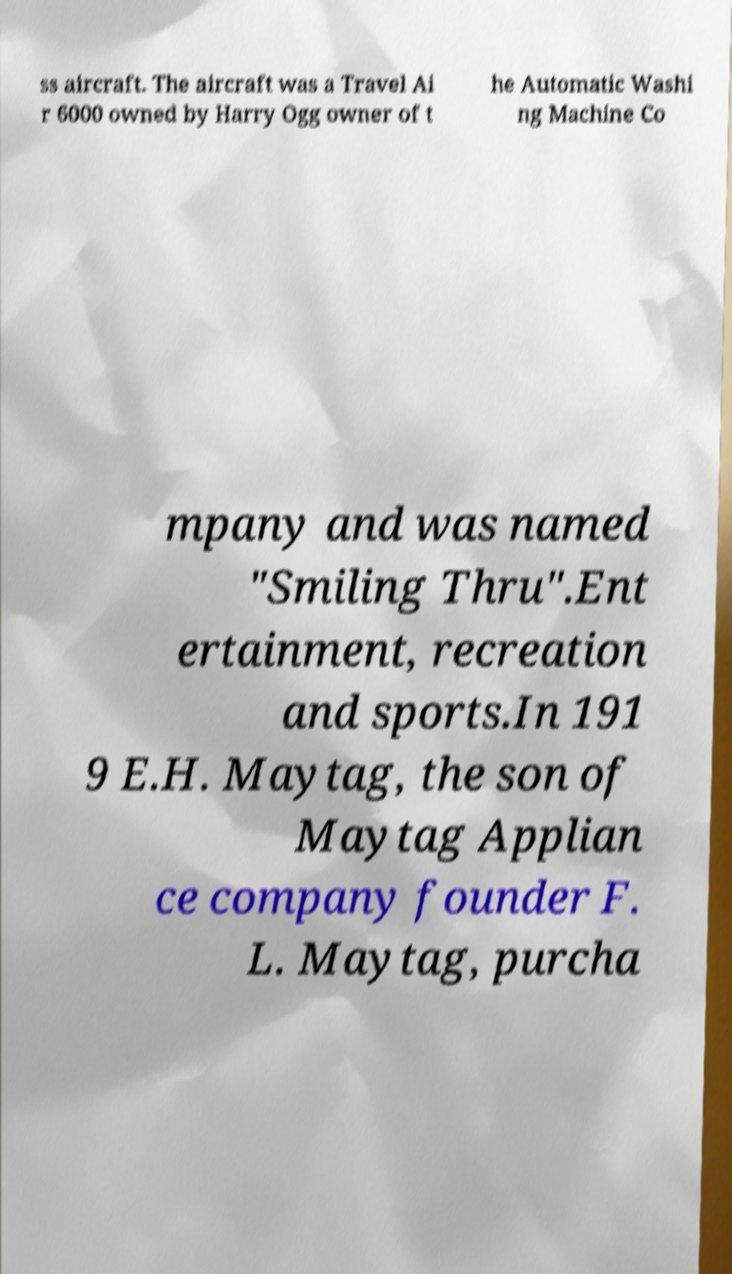What messages or text are displayed in this image? I need them in a readable, typed format. ss aircraft. The aircraft was a Travel Ai r 6000 owned by Harry Ogg owner of t he Automatic Washi ng Machine Co mpany and was named "Smiling Thru".Ent ertainment, recreation and sports.In 191 9 E.H. Maytag, the son of Maytag Applian ce company founder F. L. Maytag, purcha 